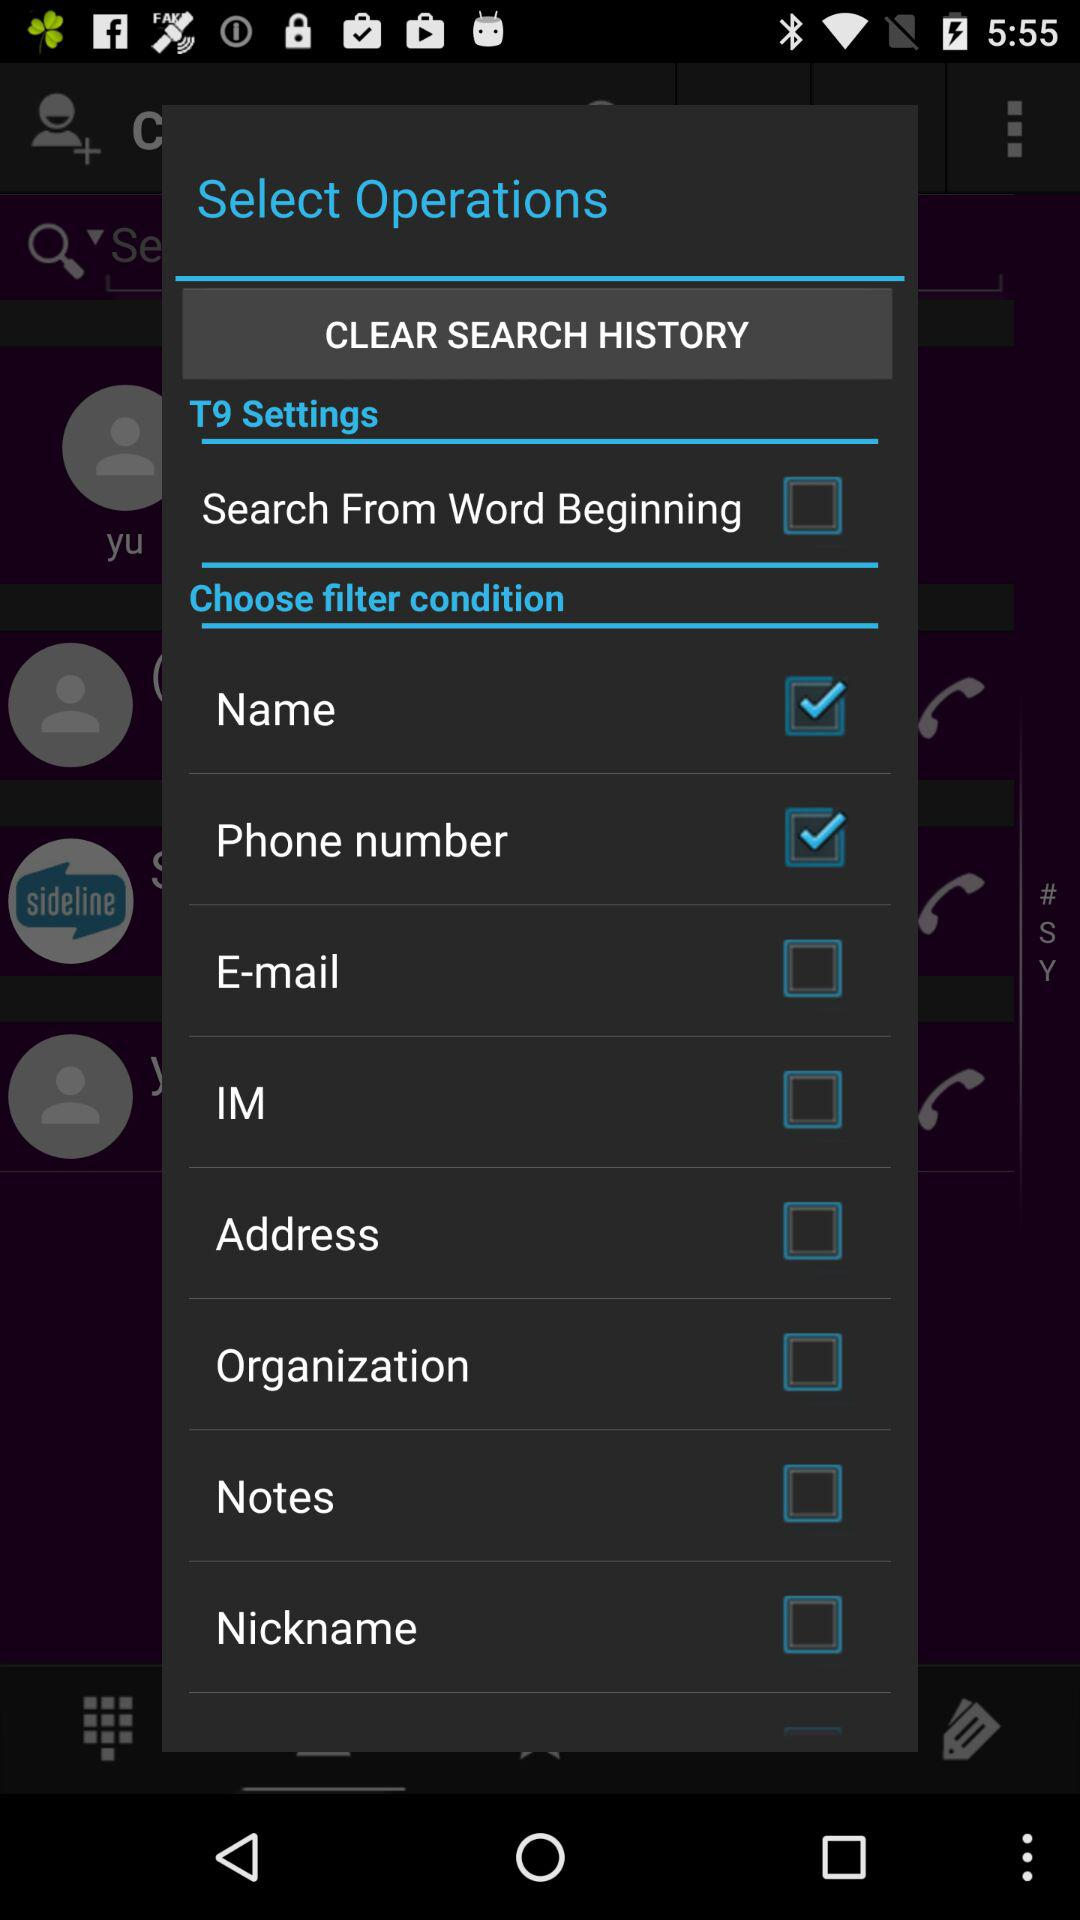What is the status of the "Name"? The status is "on". 